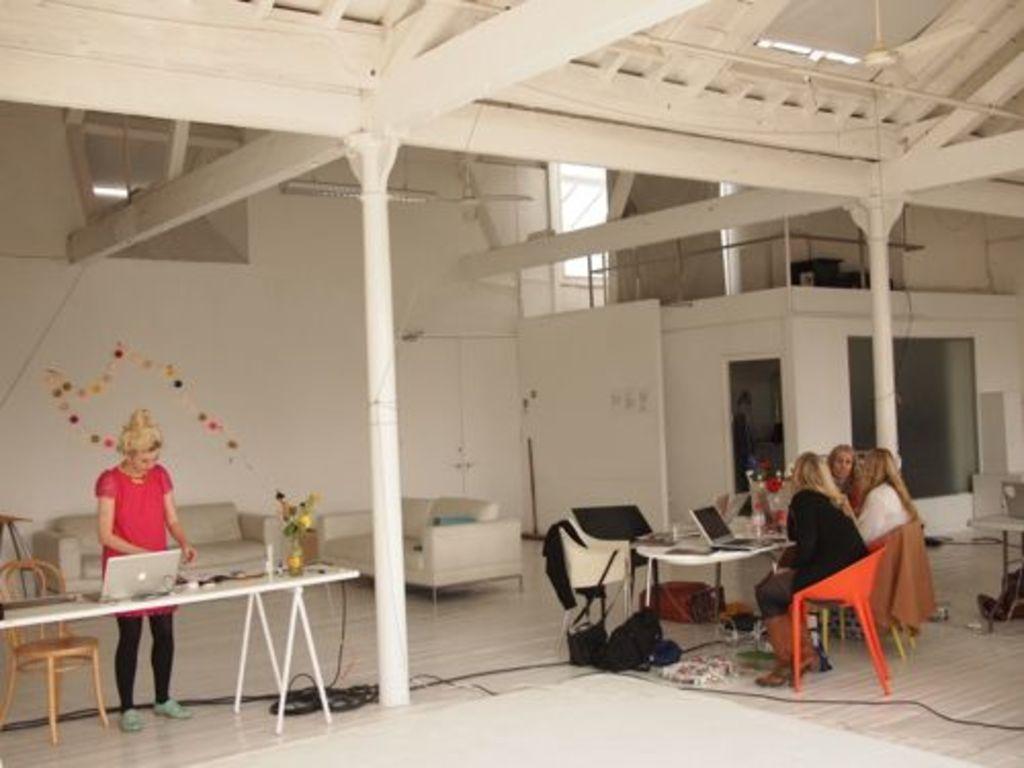Please provide a concise description of this image. In this image I can see few people are sitting on the chairs and one person is standing. I can see few laptops, flower pot and few objects on the tables. Back I can see few couches, pillow, wall, pillars, glass and few objects on the floor. The wall is in white color. 